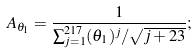Convert formula to latex. <formula><loc_0><loc_0><loc_500><loc_500>A _ { \theta _ { 1 } } = \frac { 1 } { \sum _ { j = 1 } ^ { 2 1 7 } ( \theta _ { 1 } ) ^ { j } / \sqrt { j + 2 3 } } ;</formula> 